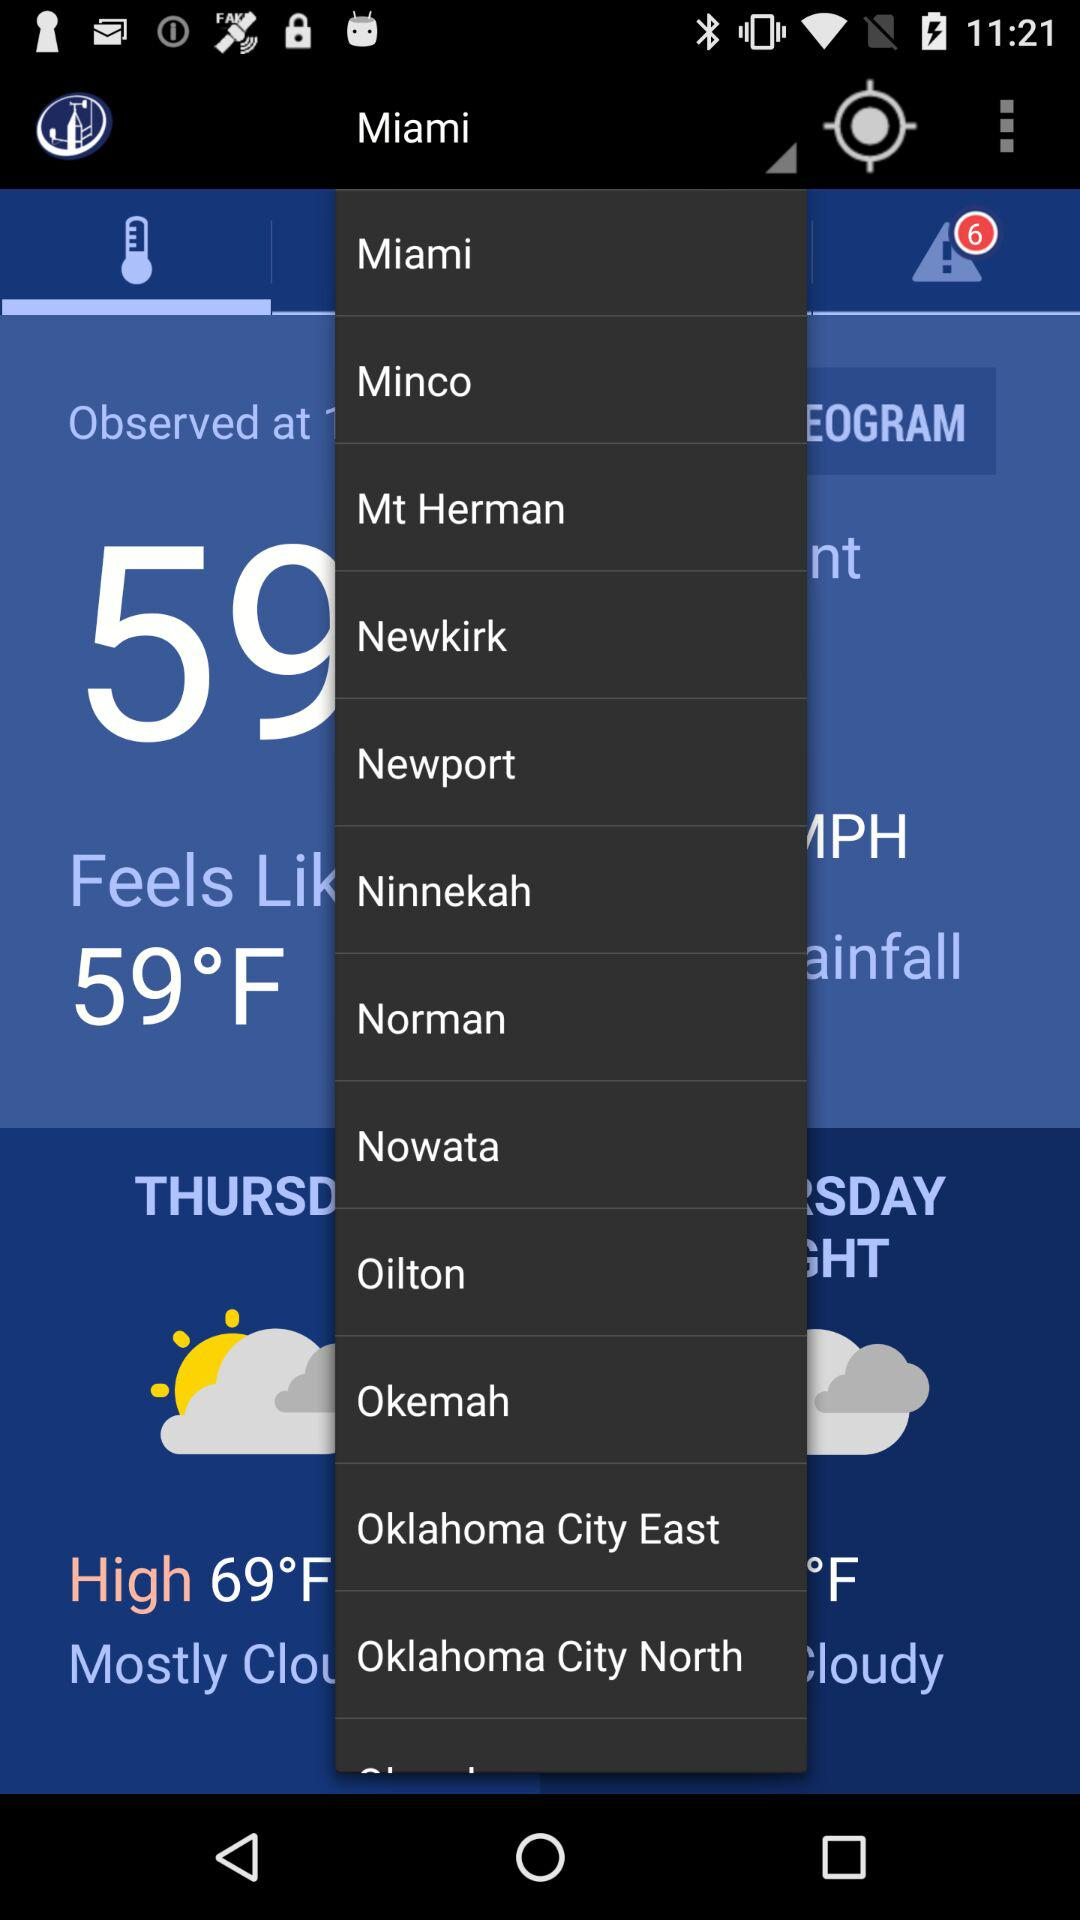Which city is selected? The selected city is Miami. 